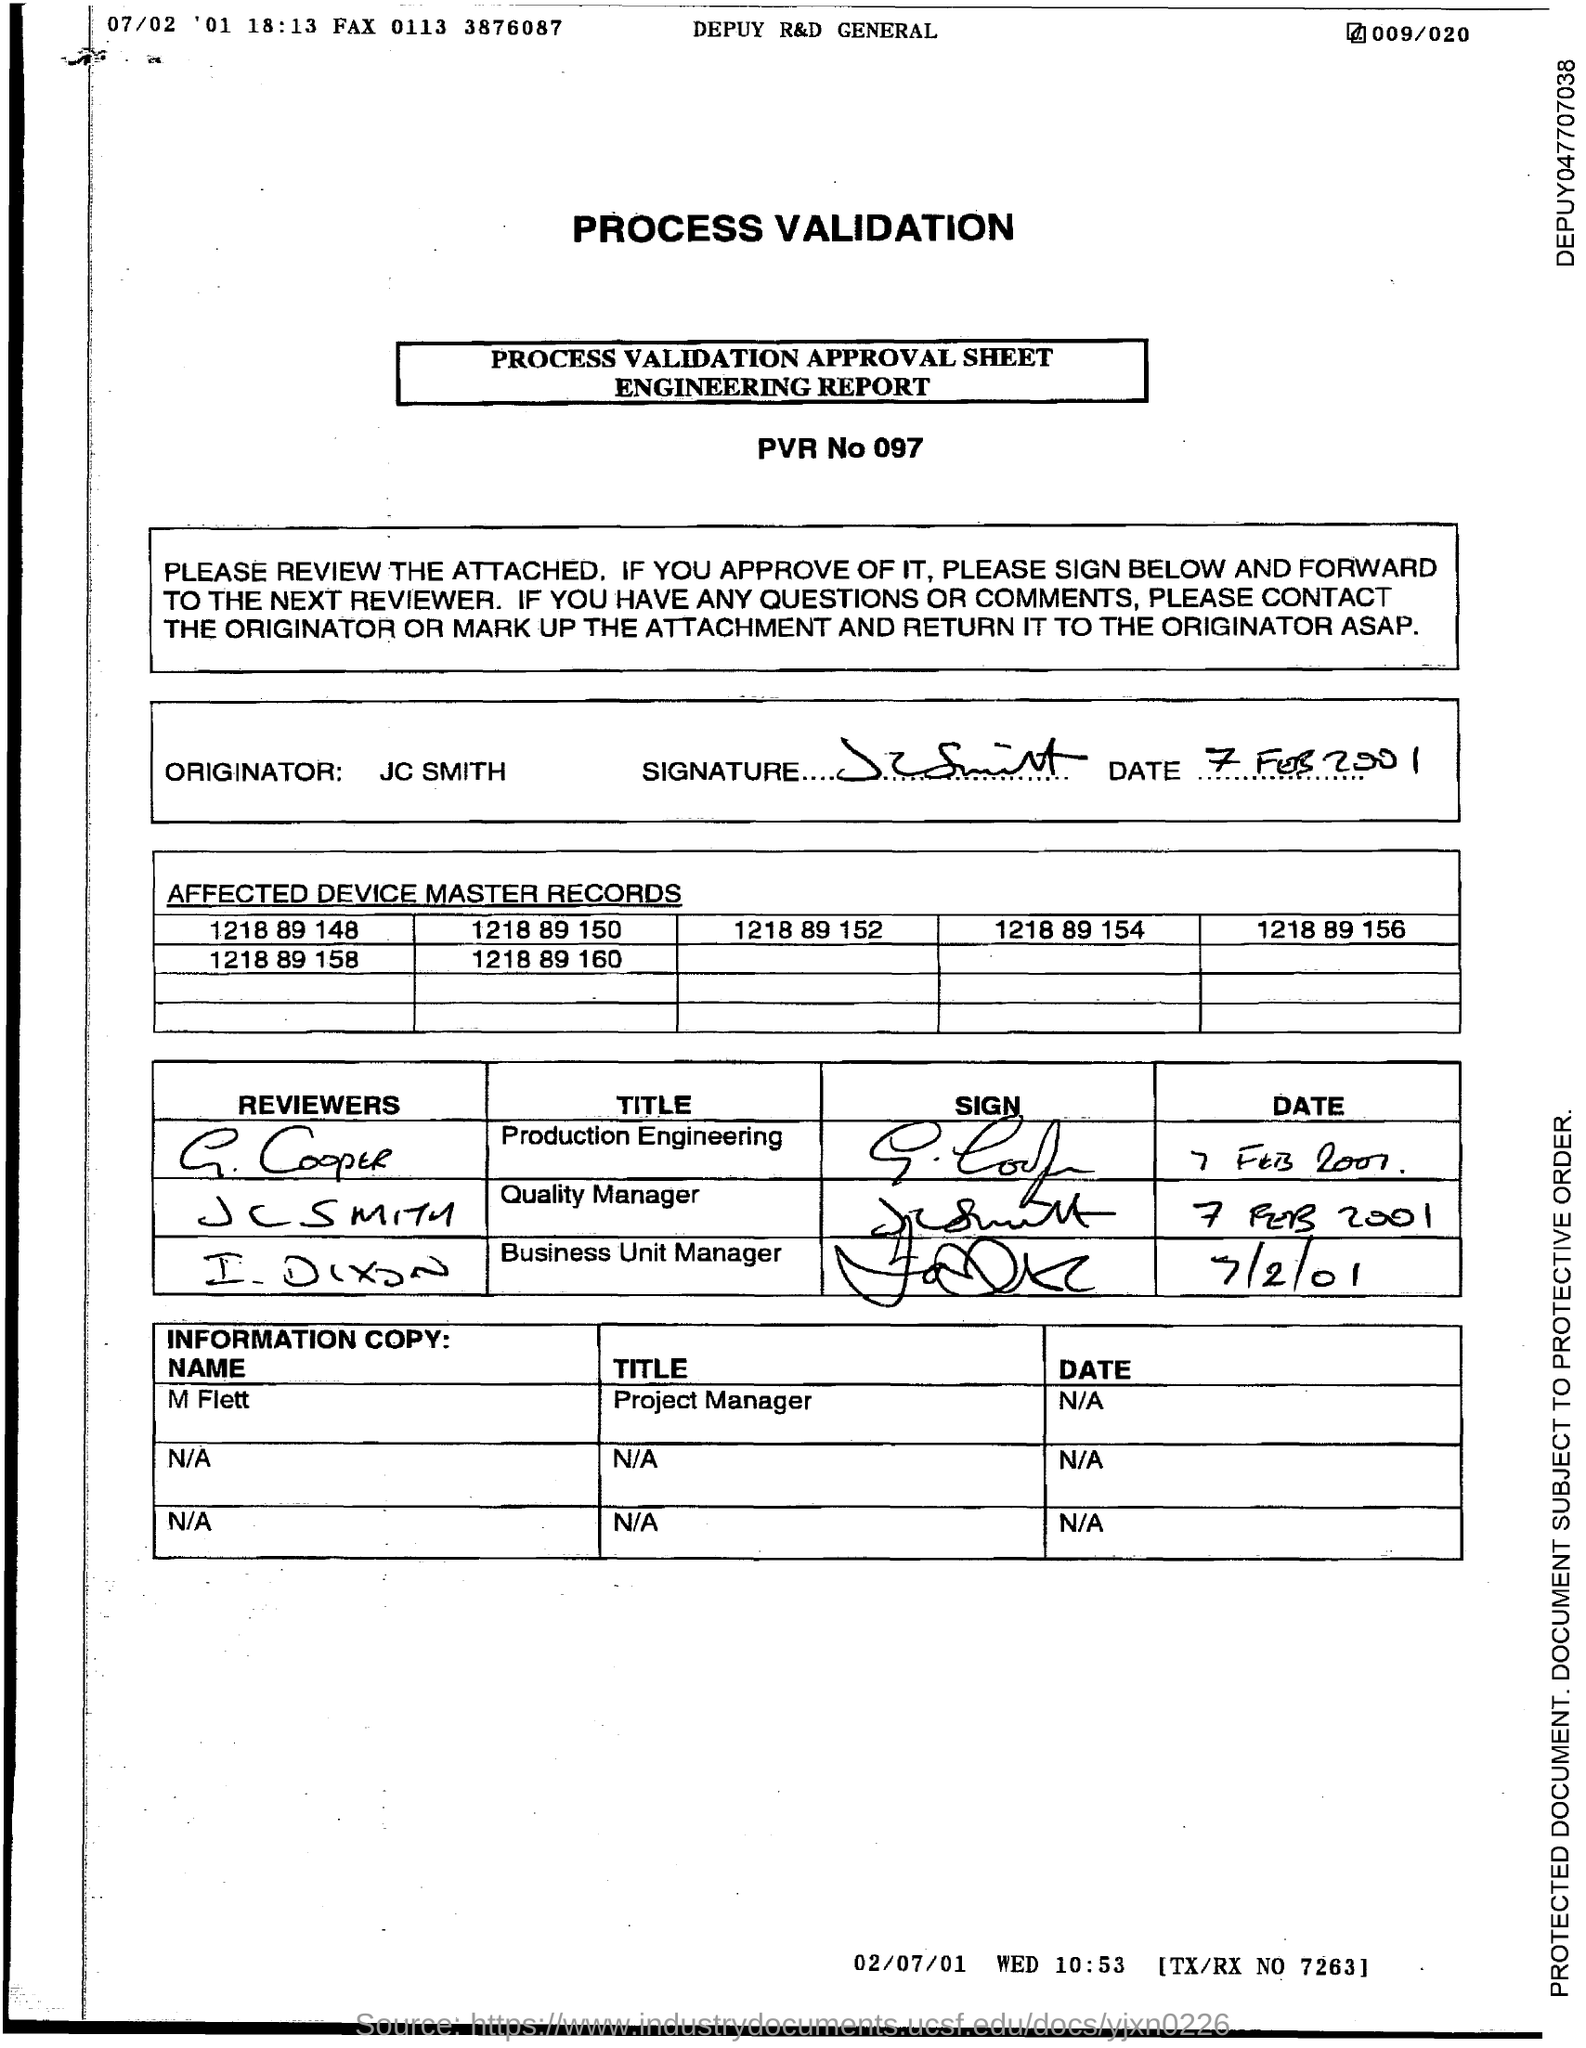What is the pvr no. ?
Offer a terse response. 097. What is the title of m flett ?
Your answer should be very brief. Project manager. 